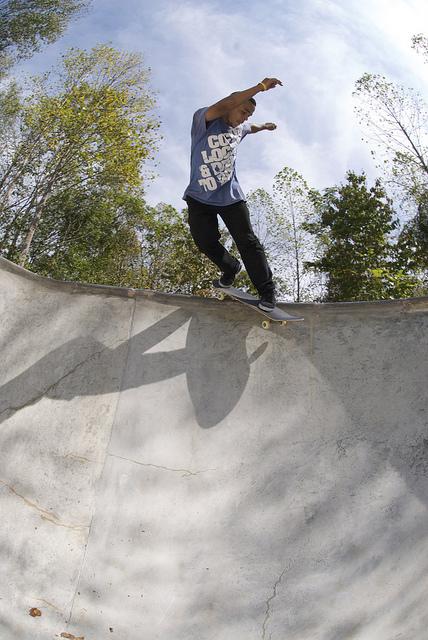Is this a safe sport?
Write a very short answer. No. Is he good at this sport?
Write a very short answer. Yes. What is he doing?
Short answer required. Skateboarding. 